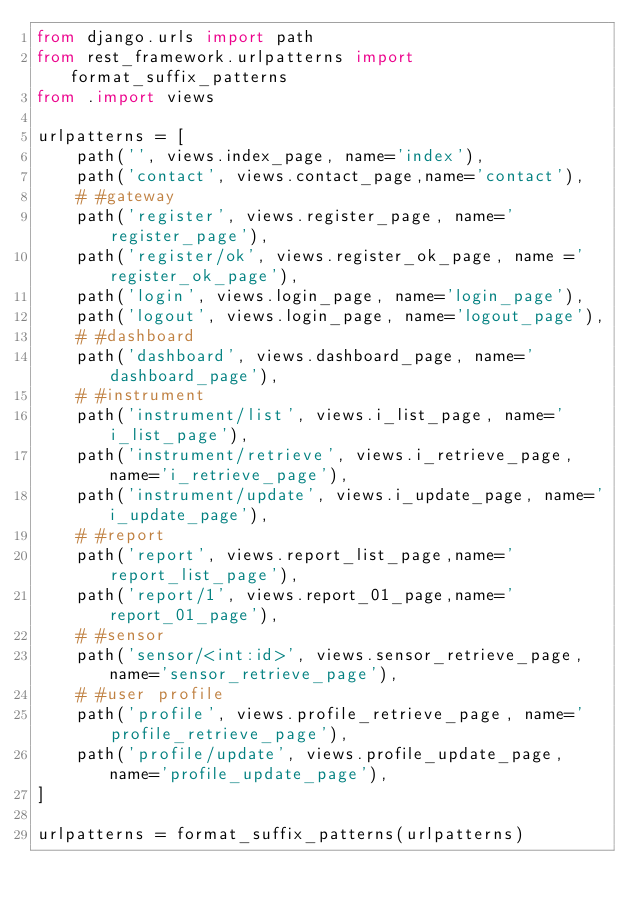<code> <loc_0><loc_0><loc_500><loc_500><_Python_>from django.urls import path
from rest_framework.urlpatterns import format_suffix_patterns
from .import views

urlpatterns = [
    path('', views.index_page, name='index'),
    path('contact', views.contact_page,name='contact'),
    # #gateway
    path('register', views.register_page, name='register_page'),
    path('register/ok', views.register_ok_page, name ='register_ok_page'),
    path('login', views.login_page, name='login_page'),
    path('logout', views.login_page, name='logout_page'),
    # #dashboard
    path('dashboard', views.dashboard_page, name='dashboard_page'),
    # #instrument
    path('instrument/list', views.i_list_page, name='i_list_page'),
    path('instrument/retrieve', views.i_retrieve_page, name='i_retrieve_page'),
    path('instrument/update', views.i_update_page, name='i_update_page'),
    # #report
    path('report', views.report_list_page,name='report_list_page'),
    path('report/1', views.report_01_page,name='report_01_page'),
    # #sensor
    path('sensor/<int:id>', views.sensor_retrieve_page, name='sensor_retrieve_page'),
    # #user profile
    path('profile', views.profile_retrieve_page, name='profile_retrieve_page'),
    path('profile/update', views.profile_update_page, name='profile_update_page'),
]

urlpatterns = format_suffix_patterns(urlpatterns)
</code> 